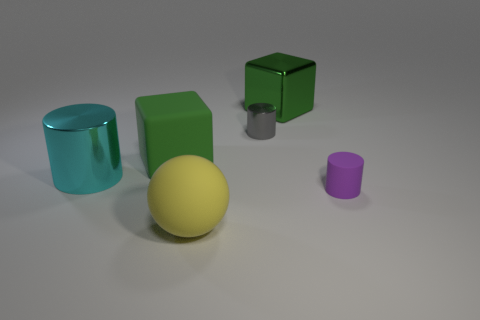Add 1 tiny gray rubber spheres. How many objects exist? 7 Subtract all spheres. How many objects are left? 5 Add 4 small gray metallic things. How many small gray metallic things exist? 5 Subtract 0 green balls. How many objects are left? 6 Subtract all big yellow spheres. Subtract all balls. How many objects are left? 4 Add 2 matte cylinders. How many matte cylinders are left? 3 